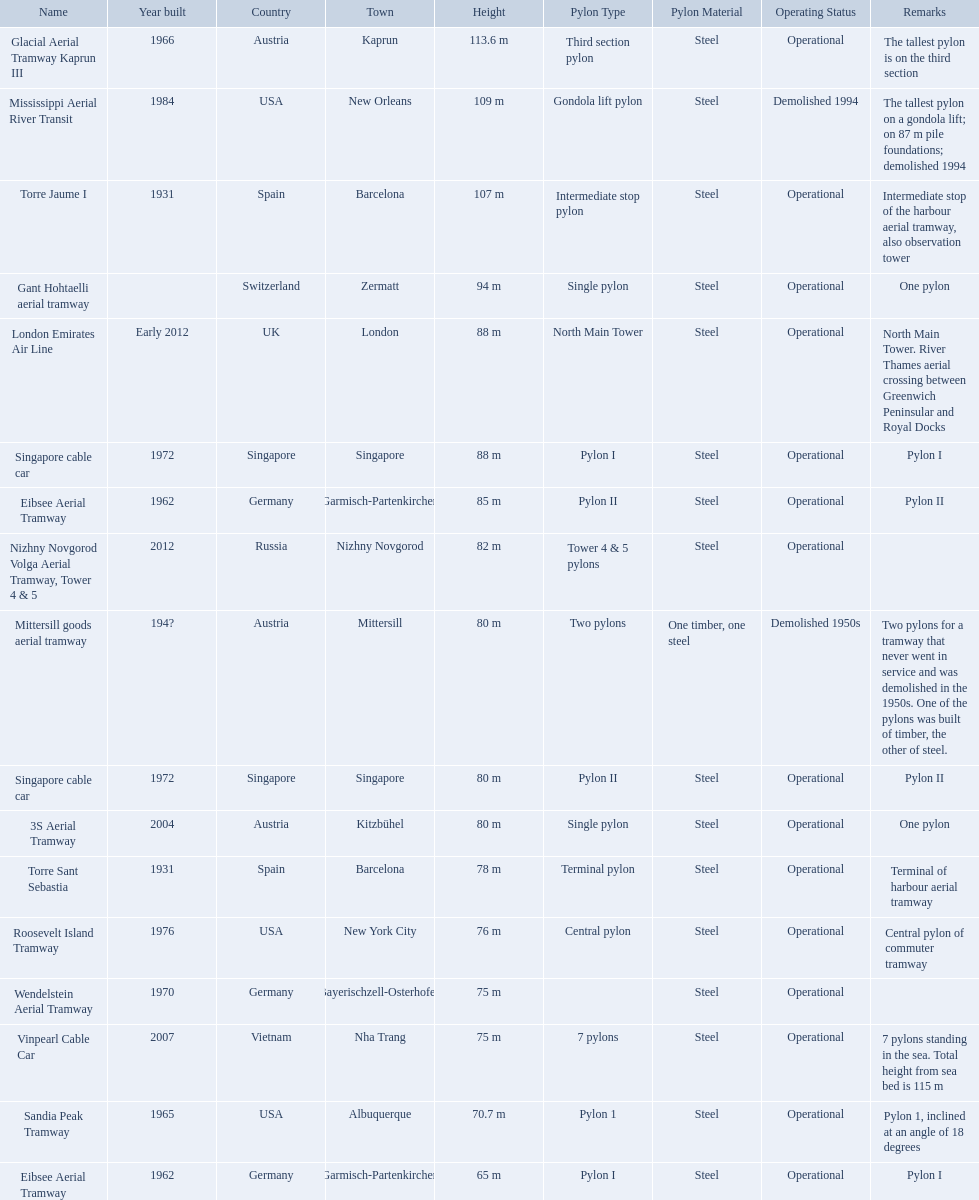How many aerial lift pylon's on the list are located in the usa? Mississippi Aerial River Transit, Roosevelt Island Tramway, Sandia Peak Tramway. Of the pylon's located in the usa how many were built after 1970? Mississippi Aerial River Transit, Roosevelt Island Tramway. Of the pylon's built after 1970 which is the tallest pylon on a gondola lift? Mississippi Aerial River Transit. How many meters is the tallest pylon on a gondola lift? 109 m. 